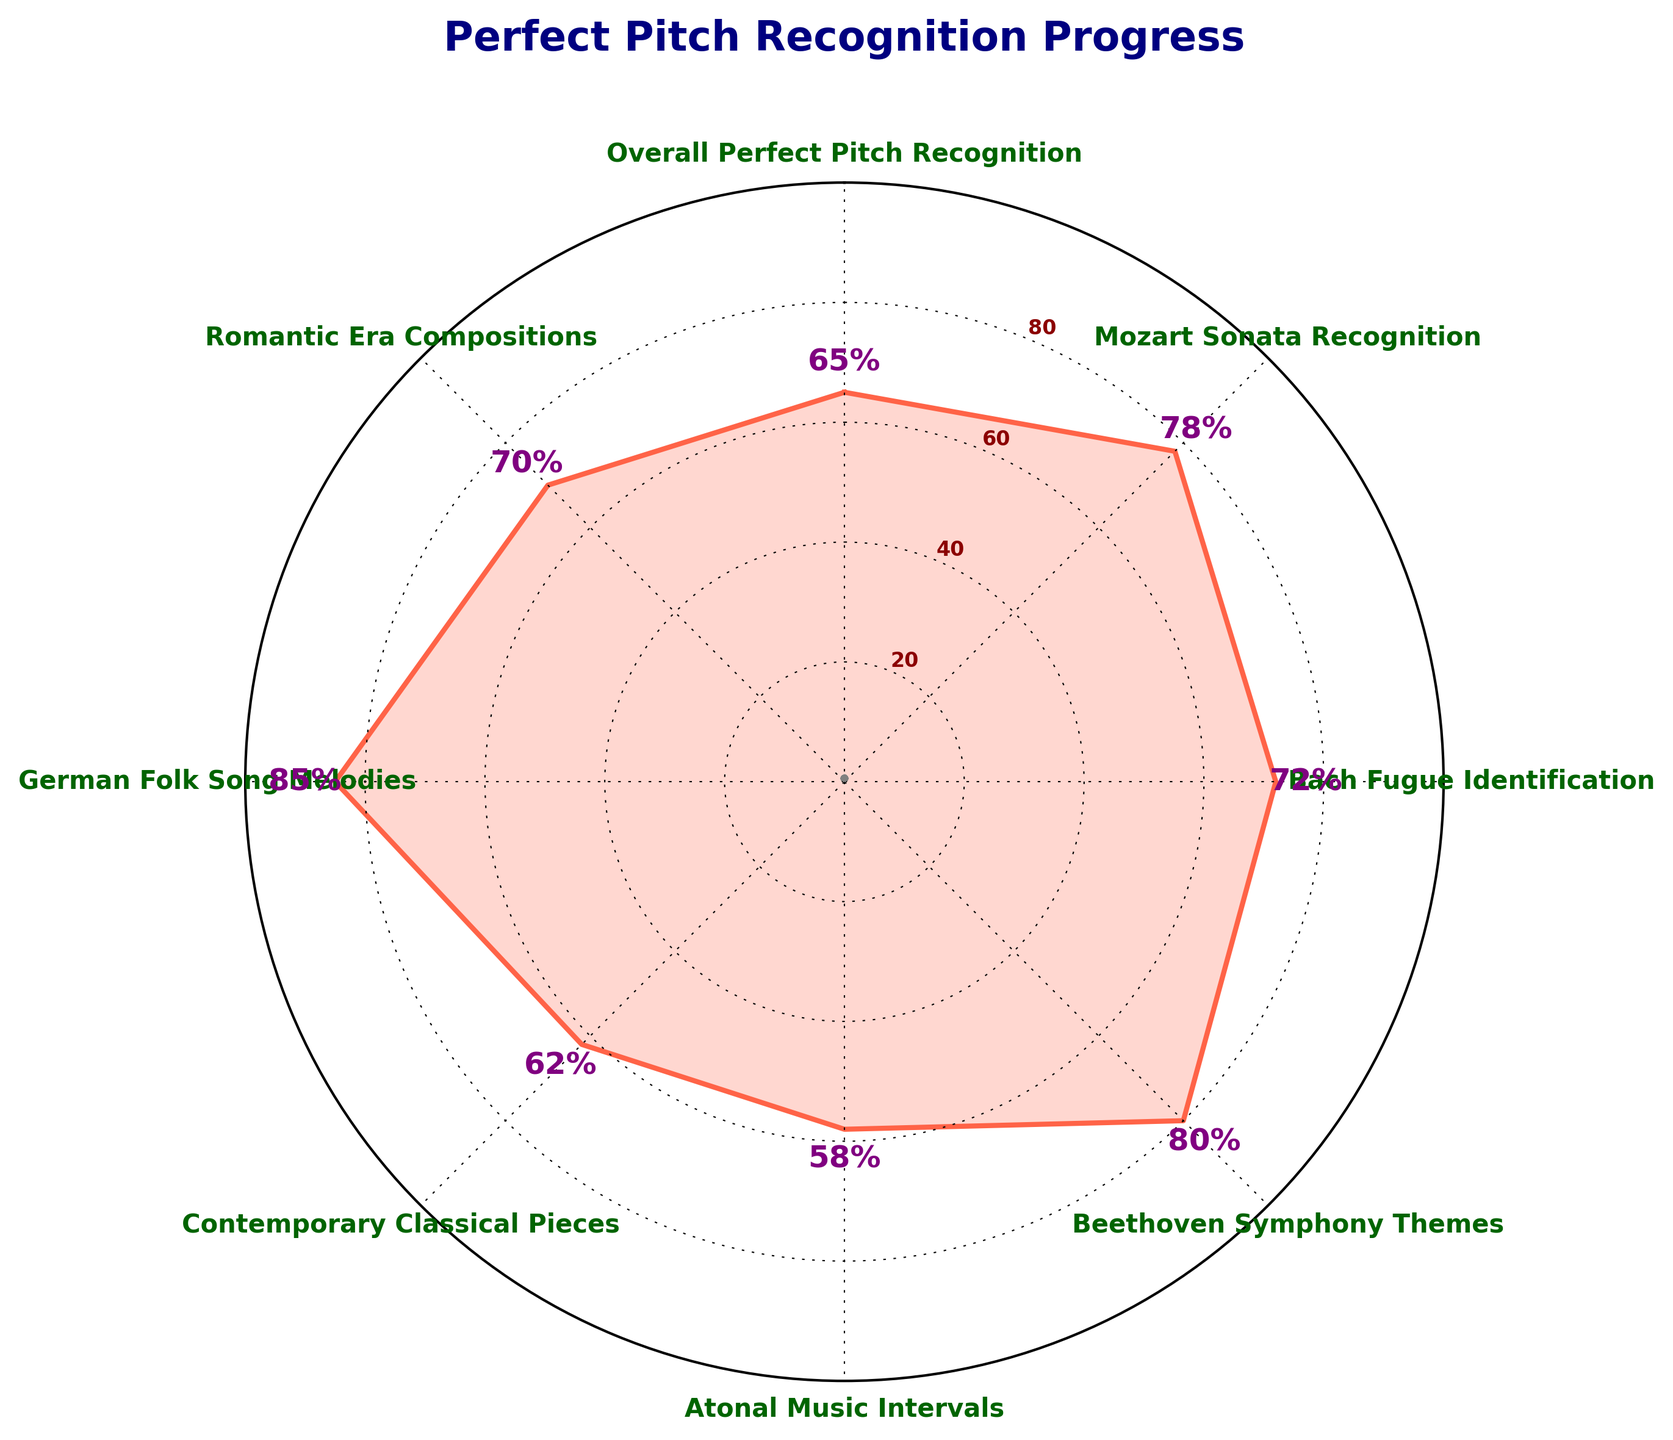What's the title of the figure? The title of the figure is displayed at the top of the chart in bold navy color.
Answer: Perfect Pitch Recognition Progress How many categories are displayed on the chart? Count the number of labels around the polar chart, excluding the repeated final label.
Answer: 8 Which category has the highest perfect pitch recognition value? Locate the category with the highest label percentage around the chart.
Answer: German Folk Song Melodies What is the value for Beethoven Symphony Themes? Find the label "Beethoven Symphony Themes" and read the percentage value next to it.
Answer: 80% Which categories have a recognition value greater than 75? Identify the categories with percentage values above 75 by looking at the numeric labels.
Answer: Mozart Sonata Recognition, Beethoven Symphony Themes, German Folk Song Melodies What's the average recognition value across all categories? Sum up all the values (65+78+72+80+58+62+85+70) and then divide by the number of categories (8).
Answer: 71.25% How much higher is the recognition value for German Folk Song Melodies compared to Atonal Music Intervals? Subtract the value for Atonal Music Intervals (58) from the value for German Folk Song Melodies (85).
Answer: 27% What is the median recognition value? Order the values: 58, 62, 65, 70, 72, 78, 80, 85. The median is the average of the 4th and 5th values (70 and 72).
Answer: 71% Which category has the second lowest recognition value? Identify and rank the values in ascending order to find the second lowest.
Answer: Contemporary Classical Pieces Is there any category that has a recognition value within ±5 of the overall average? Calculate the range of the average ±5, which is 66.25 to 76.25, and check which categories' values fall within this range (none do).
Answer: No 